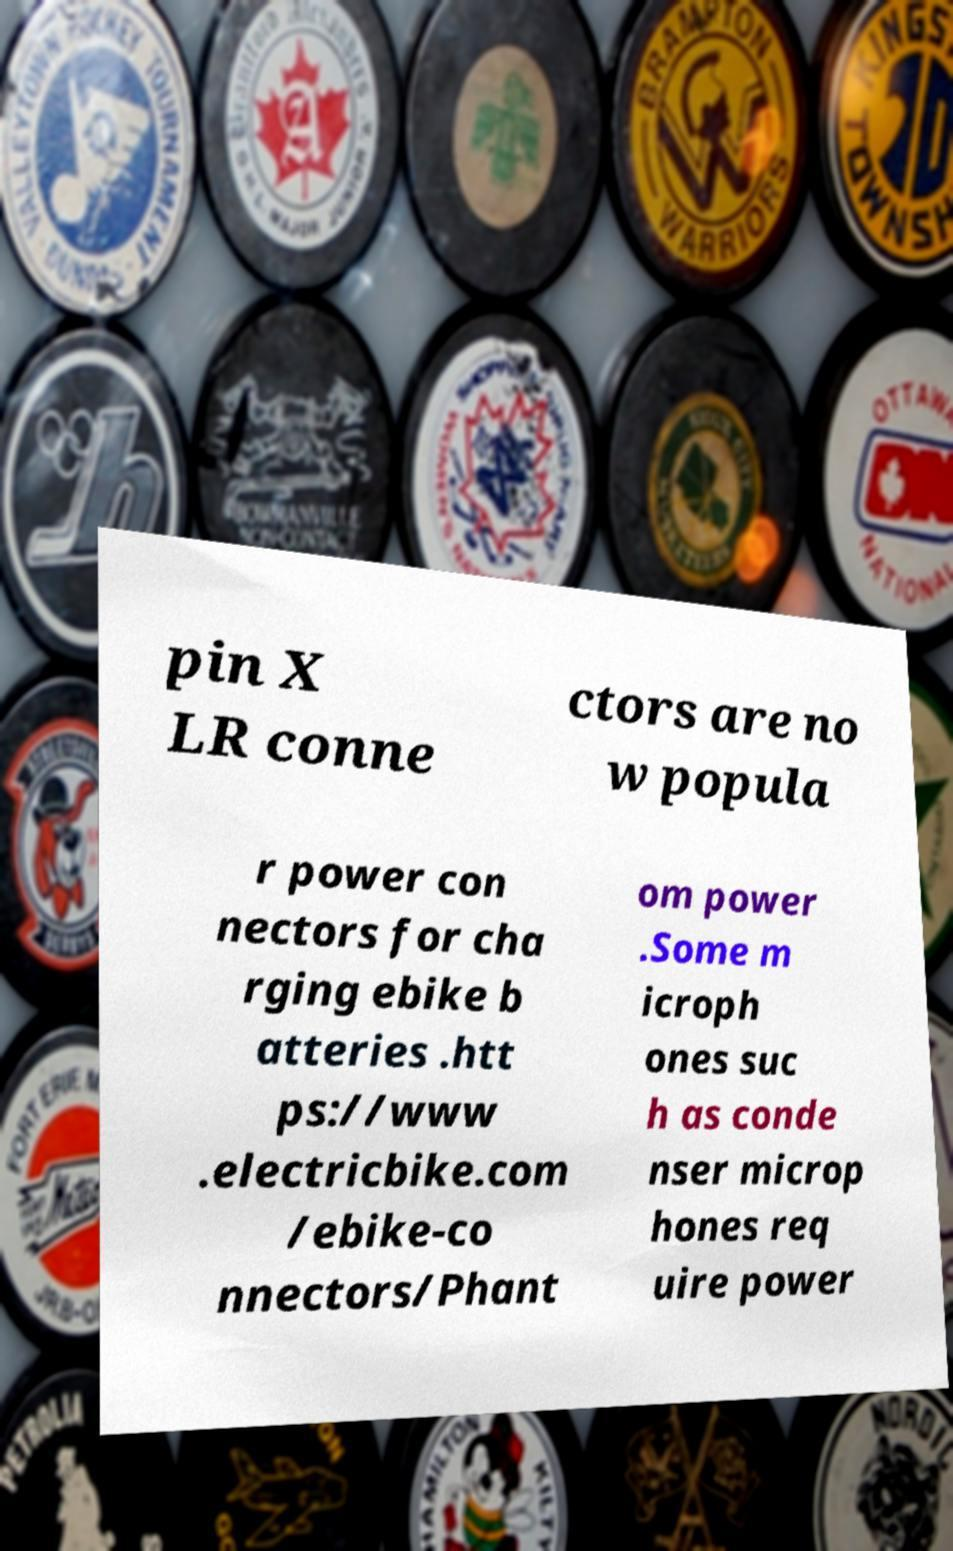For documentation purposes, I need the text within this image transcribed. Could you provide that? pin X LR conne ctors are no w popula r power con nectors for cha rging ebike b atteries .htt ps://www .electricbike.com /ebike-co nnectors/Phant om power .Some m icroph ones suc h as conde nser microp hones req uire power 